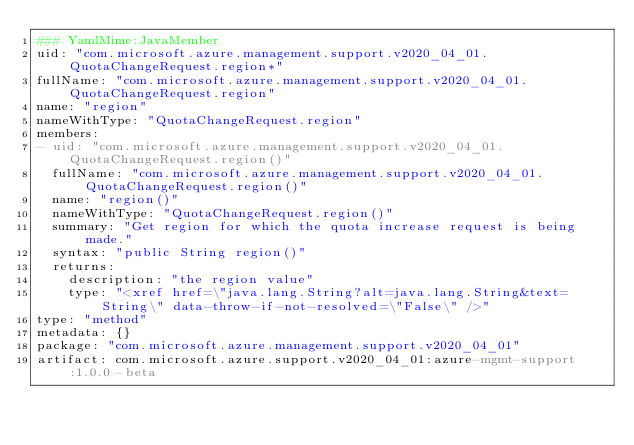<code> <loc_0><loc_0><loc_500><loc_500><_YAML_>### YamlMime:JavaMember
uid: "com.microsoft.azure.management.support.v2020_04_01.QuotaChangeRequest.region*"
fullName: "com.microsoft.azure.management.support.v2020_04_01.QuotaChangeRequest.region"
name: "region"
nameWithType: "QuotaChangeRequest.region"
members:
- uid: "com.microsoft.azure.management.support.v2020_04_01.QuotaChangeRequest.region()"
  fullName: "com.microsoft.azure.management.support.v2020_04_01.QuotaChangeRequest.region()"
  name: "region()"
  nameWithType: "QuotaChangeRequest.region()"
  summary: "Get region for which the quota increase request is being made."
  syntax: "public String region()"
  returns:
    description: "the region value"
    type: "<xref href=\"java.lang.String?alt=java.lang.String&text=String\" data-throw-if-not-resolved=\"False\" />"
type: "method"
metadata: {}
package: "com.microsoft.azure.management.support.v2020_04_01"
artifact: com.microsoft.azure.support.v2020_04_01:azure-mgmt-support:1.0.0-beta
</code> 